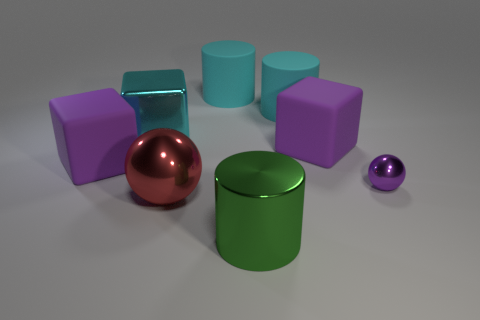The cylinder that is in front of the purple matte cube that is to the right of the big metal cylinder is what color?
Provide a succinct answer. Green. How many other things are made of the same material as the green thing?
Your response must be concise. 3. Is the number of large brown blocks the same as the number of small purple things?
Provide a succinct answer. No. How many shiny things are large blocks or cyan cylinders?
Offer a very short reply. 1. There is a small metallic thing that is the same shape as the large red metal thing; what is its color?
Ensure brevity in your answer.  Purple. What number of objects are tiny purple shiny objects or big purple matte cubes?
Offer a very short reply. 3. The green thing that is the same material as the large red ball is what shape?
Your answer should be compact. Cylinder. How many small things are cyan cubes or green shiny blocks?
Keep it short and to the point. 0. What number of other objects are there of the same color as the big shiny cube?
Your answer should be very brief. 2. There is a big metallic object behind the tiny purple object that is behind the metal cylinder; how many large cyan metallic things are on the left side of it?
Ensure brevity in your answer.  0. 